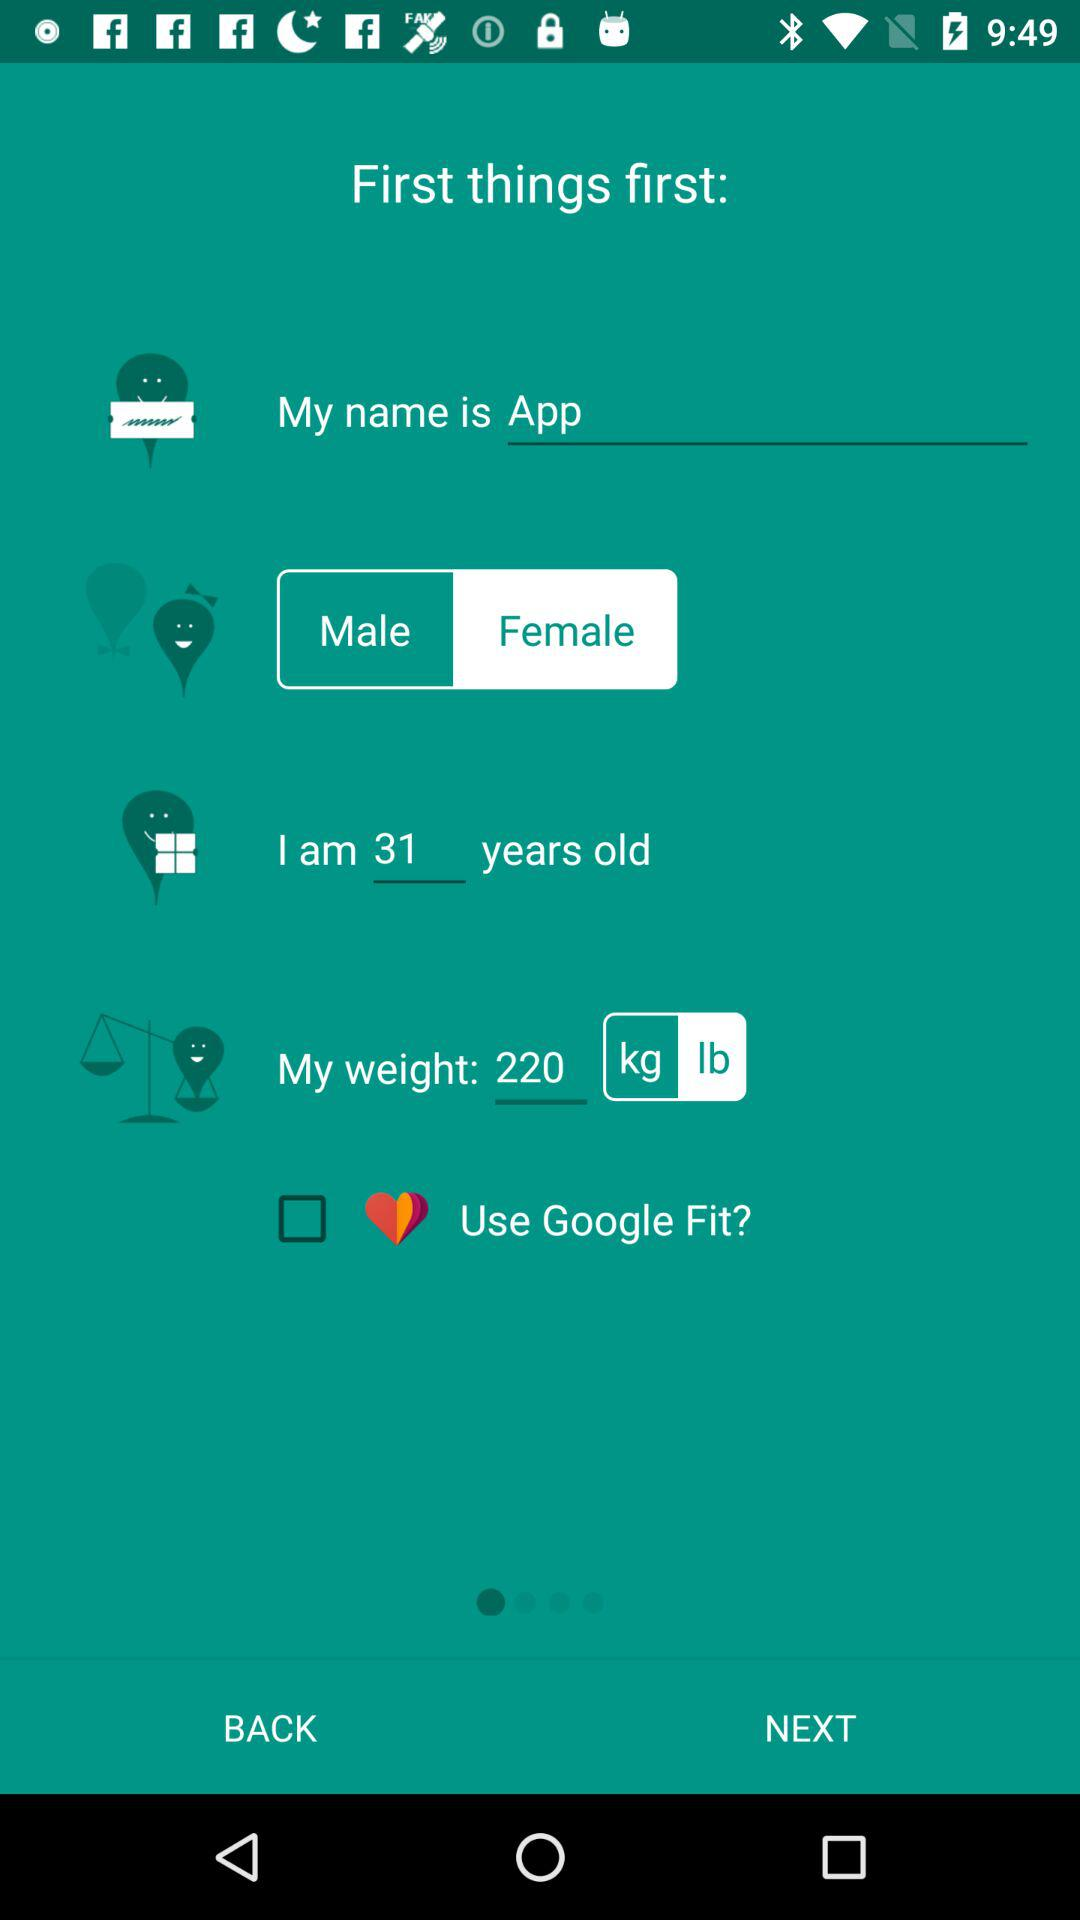The weight is measured in what unit? The weight is measured in lb. 